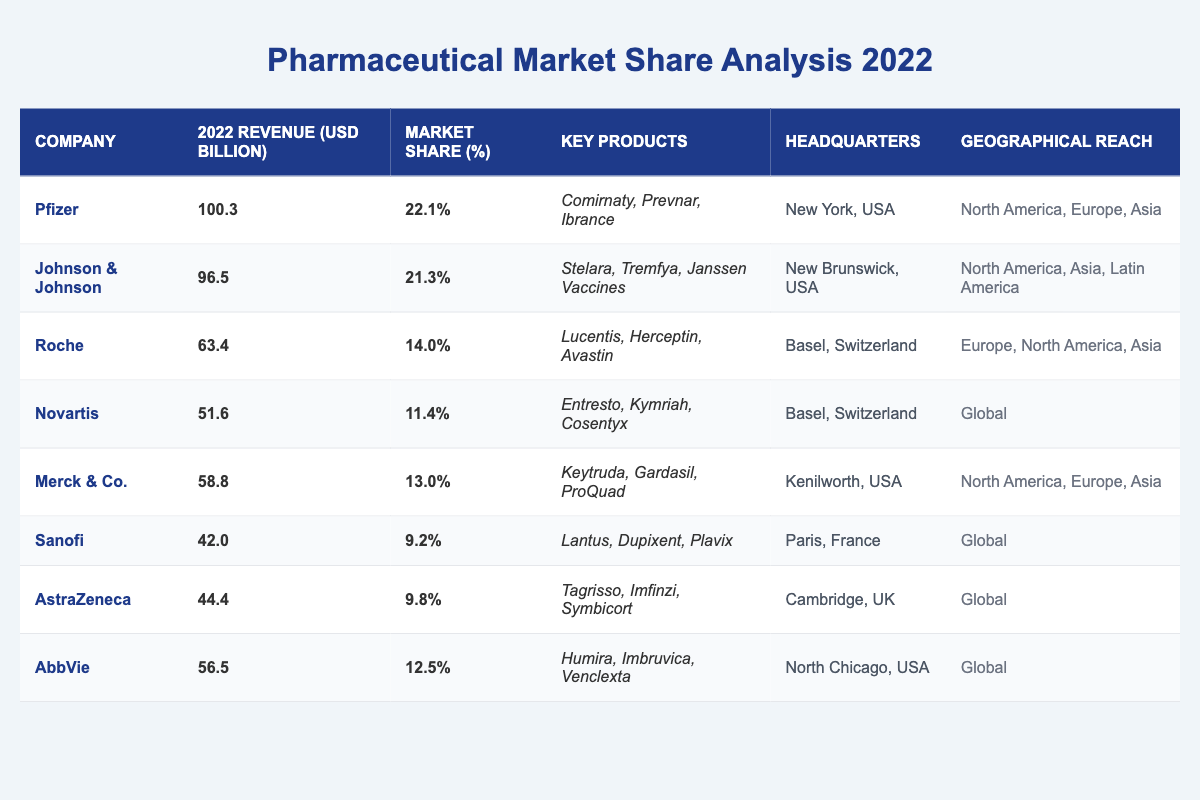What is the revenue of Roche in 2022? According to the table, Roche's revenue for 2022 is listed as 63.4 billion USD.
Answer: 63.4 billion USD Which company has the highest market share? The table indicates that Pfizer has the highest market share at 22.1%.
Answer: Pfizer What is the combined revenue of Johnson & Johnson and Merck & Co. in 2022? Johnson & Johnson’s revenue is 96.5 billion USD and Merck & Co.'s is 58.8 billion USD. Adding them together gives 96.5 + 58.8 = 155.3 billion USD.
Answer: 155.3 billion USD Which company has the lowest market share percentage? From the table, Sanofi has the lowest market share at 9.2%.
Answer: Sanofi Is Novartis headquartered in Switzerland? The headquarters of Novartis is listed in the table as Basel, Switzerland, which confirms that it is indeed headquartered there.
Answer: Yes What is the average revenue of all companies listed? The total revenue from all companies is calculated as follows: 100.3 + 96.5 + 63.4 + 51.6 + 58.8 + 42.0 + 44.4 + 56.5 = 513.3 billion USD. There are 8 companies, so the average revenue is 513.3 / 8 = 64.1625 billion USD.
Answer: 64.16 billion USD How many companies have a market share over 10%? By checking the market share percentages, we find that Pfizer (22.1%), Johnson & Johnson (21.3%), Roche (14.0%), Merck & Co. (13.0%), and AbbVie (12.5%) all have market shares over 10%. This accounts for 5 companies.
Answer: 5 companies Which company has the best geographical reach according to the table? The table shows that Novartis has a 'Global' geographical reach, which is the broadest compared to other companies that are limited to specific regions.
Answer: Novartis What is the difference in market share between Pfizer and Roche? Pfizer has a market share of 22.1%, while Roche has 14.0%. The difference is calculated as 22.1 - 14.0 = 8.1%.
Answer: 8.1% Does AstraZeneca operate in North America? AstraZeneca's geographical reach is listed as 'Global', which implies it operates in North America among other regions.
Answer: Yes 